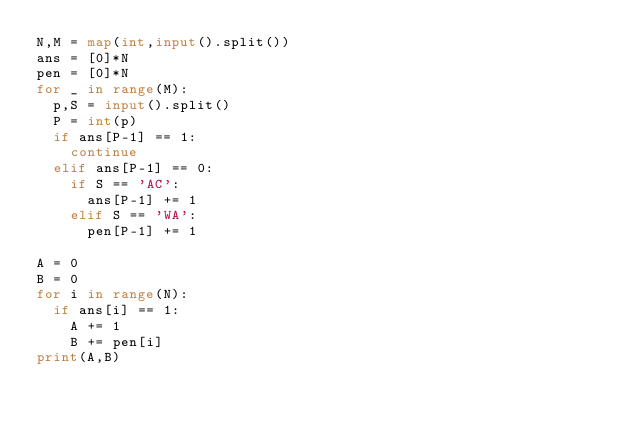<code> <loc_0><loc_0><loc_500><loc_500><_Python_>N,M = map(int,input().split())
ans = [0]*N
pen = [0]*N
for _ in range(M):
  p,S = input().split()
  P = int(p)
  if ans[P-1] == 1:
    continue
  elif ans[P-1] == 0:
    if S == 'AC':
      ans[P-1] += 1
    elif S == 'WA':
      pen[P-1] += 1
      
A = 0
B = 0 
for i in range(N):
  if ans[i] == 1:
    A += 1
    B += pen[i]
print(A,B)</code> 